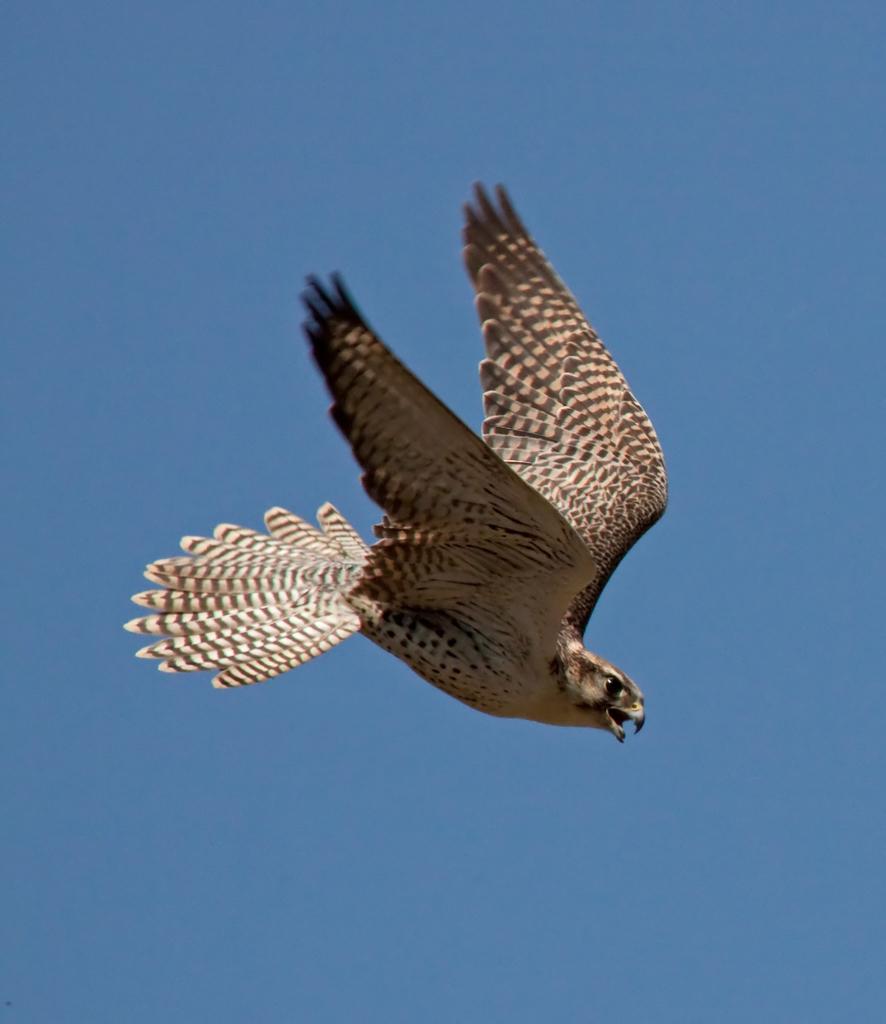Can you describe this image briefly? In this image, we can see a bird on blue background. 